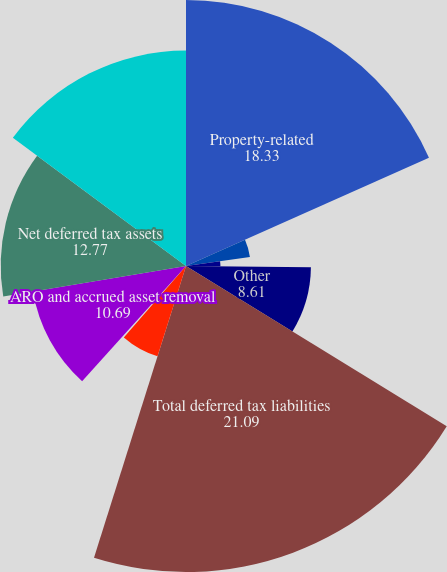Convert chart. <chart><loc_0><loc_0><loc_500><loc_500><pie_chart><fcel>Property-related<fcel>Pension<fcel>Storm reserve deficiency<fcel>Other<fcel>Total deferred tax liabilities<fcel>Decommissioning reserves<fcel>Postretirement benefits<fcel>ARO and accrued asset removal<fcel>Net deferred tax assets<fcel>Net accumulated deferred<nl><fcel>18.33%<fcel>4.45%<fcel>2.37%<fcel>8.61%<fcel>21.09%<fcel>6.53%<fcel>0.29%<fcel>10.69%<fcel>12.77%<fcel>14.85%<nl></chart> 